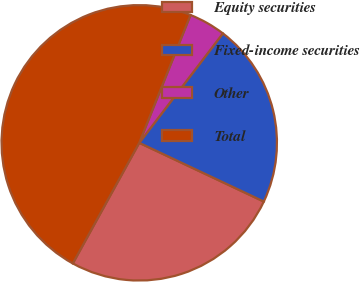<chart> <loc_0><loc_0><loc_500><loc_500><pie_chart><fcel>Equity securities<fcel>Fixed-income securities<fcel>Other<fcel>Total<nl><fcel>26.0%<fcel>21.62%<fcel>4.32%<fcel>48.05%<nl></chart> 